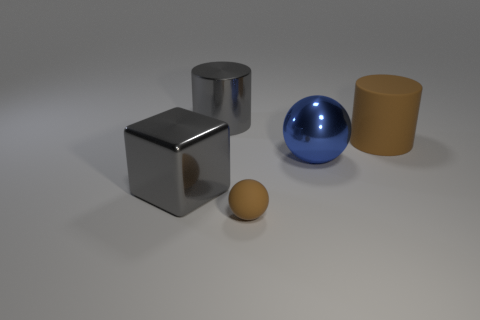Add 4 large metallic cubes. How many objects exist? 9 Subtract all balls. How many objects are left? 3 Subtract all small gray rubber cubes. Subtract all large metallic cubes. How many objects are left? 4 Add 4 big cubes. How many big cubes are left? 5 Add 5 shiny blocks. How many shiny blocks exist? 6 Subtract 0 cyan blocks. How many objects are left? 5 